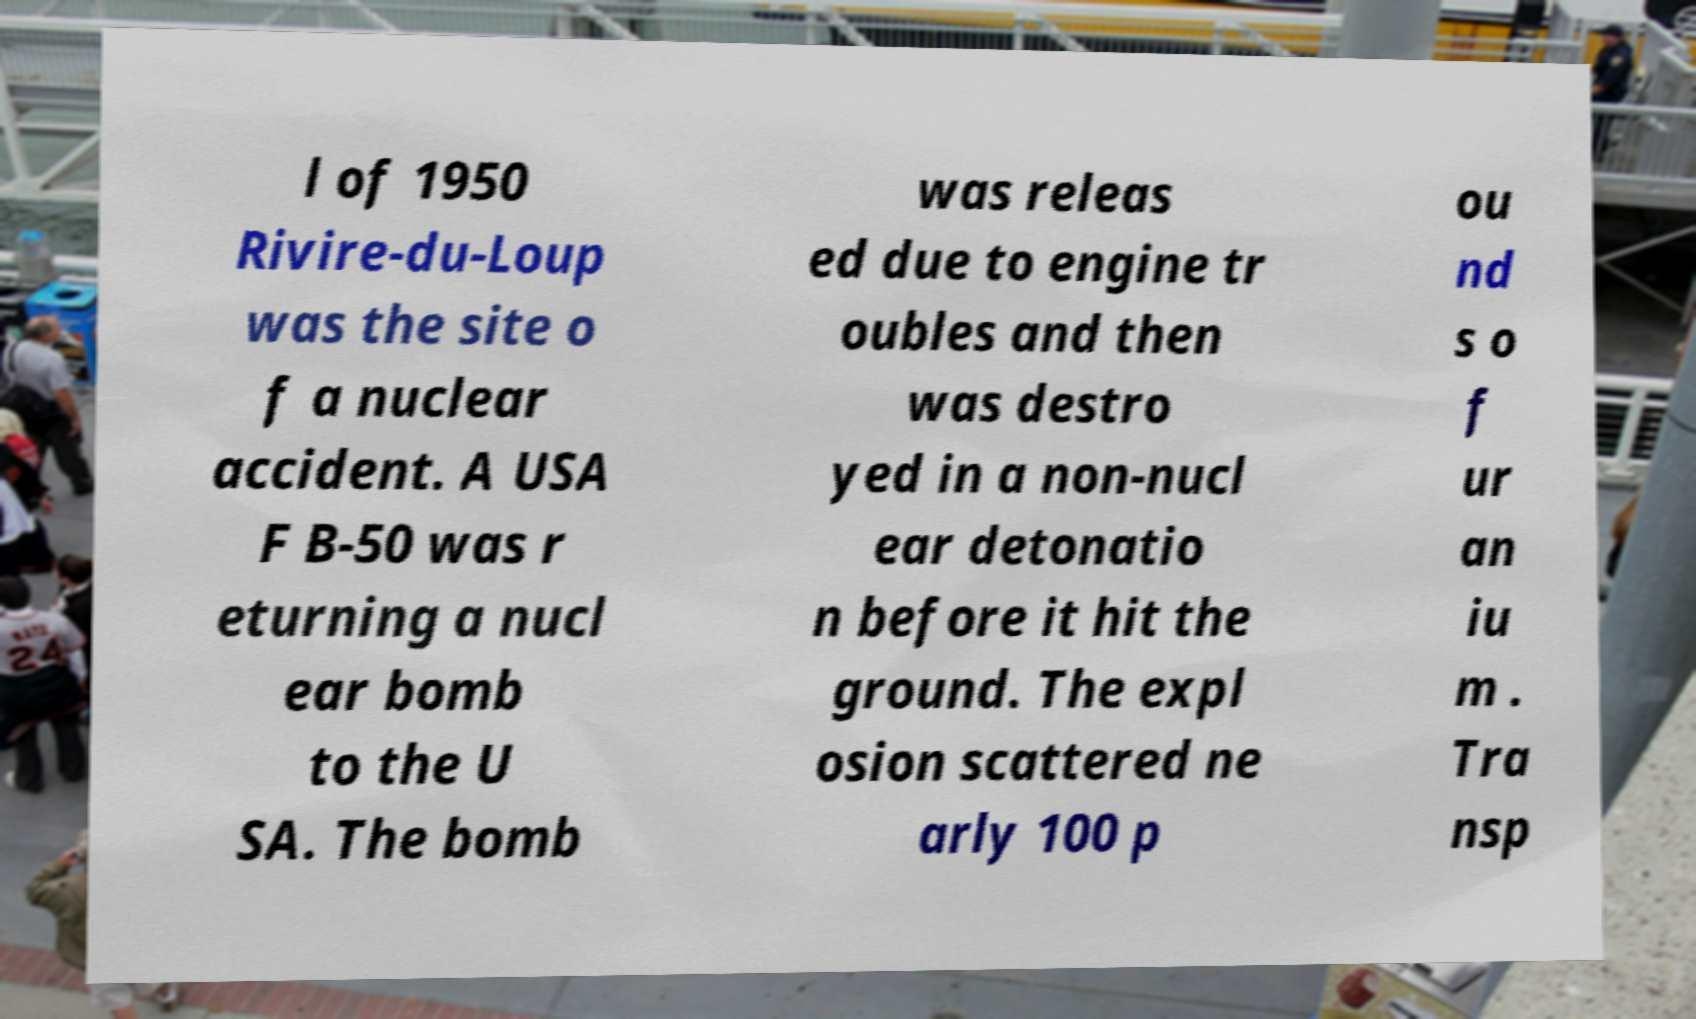What messages or text are displayed in this image? I need them in a readable, typed format. l of 1950 Rivire-du-Loup was the site o f a nuclear accident. A USA F B-50 was r eturning a nucl ear bomb to the U SA. The bomb was releas ed due to engine tr oubles and then was destro yed in a non-nucl ear detonatio n before it hit the ground. The expl osion scattered ne arly 100 p ou nd s o f ur an iu m . Tra nsp 